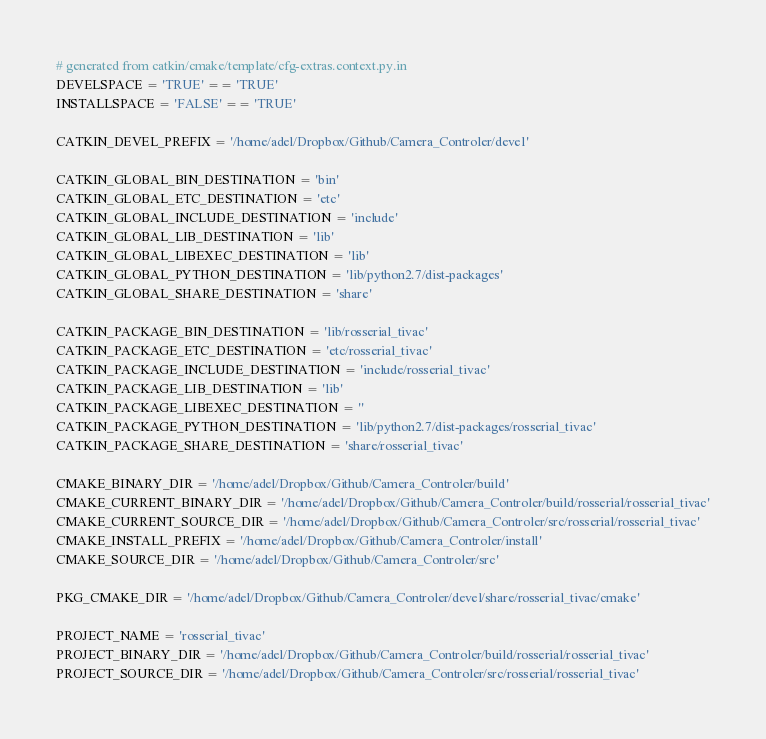<code> <loc_0><loc_0><loc_500><loc_500><_Python_># generated from catkin/cmake/template/cfg-extras.context.py.in
DEVELSPACE = 'TRUE' == 'TRUE'
INSTALLSPACE = 'FALSE' == 'TRUE'

CATKIN_DEVEL_PREFIX = '/home/adel/Dropbox/Github/Camera_Controler/devel'

CATKIN_GLOBAL_BIN_DESTINATION = 'bin'
CATKIN_GLOBAL_ETC_DESTINATION = 'etc'
CATKIN_GLOBAL_INCLUDE_DESTINATION = 'include'
CATKIN_GLOBAL_LIB_DESTINATION = 'lib'
CATKIN_GLOBAL_LIBEXEC_DESTINATION = 'lib'
CATKIN_GLOBAL_PYTHON_DESTINATION = 'lib/python2.7/dist-packages'
CATKIN_GLOBAL_SHARE_DESTINATION = 'share'

CATKIN_PACKAGE_BIN_DESTINATION = 'lib/rosserial_tivac'
CATKIN_PACKAGE_ETC_DESTINATION = 'etc/rosserial_tivac'
CATKIN_PACKAGE_INCLUDE_DESTINATION = 'include/rosserial_tivac'
CATKIN_PACKAGE_LIB_DESTINATION = 'lib'
CATKIN_PACKAGE_LIBEXEC_DESTINATION = ''
CATKIN_PACKAGE_PYTHON_DESTINATION = 'lib/python2.7/dist-packages/rosserial_tivac'
CATKIN_PACKAGE_SHARE_DESTINATION = 'share/rosserial_tivac'

CMAKE_BINARY_DIR = '/home/adel/Dropbox/Github/Camera_Controler/build'
CMAKE_CURRENT_BINARY_DIR = '/home/adel/Dropbox/Github/Camera_Controler/build/rosserial/rosserial_tivac'
CMAKE_CURRENT_SOURCE_DIR = '/home/adel/Dropbox/Github/Camera_Controler/src/rosserial/rosserial_tivac'
CMAKE_INSTALL_PREFIX = '/home/adel/Dropbox/Github/Camera_Controler/install'
CMAKE_SOURCE_DIR = '/home/adel/Dropbox/Github/Camera_Controler/src'

PKG_CMAKE_DIR = '/home/adel/Dropbox/Github/Camera_Controler/devel/share/rosserial_tivac/cmake'

PROJECT_NAME = 'rosserial_tivac'
PROJECT_BINARY_DIR = '/home/adel/Dropbox/Github/Camera_Controler/build/rosserial/rosserial_tivac'
PROJECT_SOURCE_DIR = '/home/adel/Dropbox/Github/Camera_Controler/src/rosserial/rosserial_tivac'
</code> 